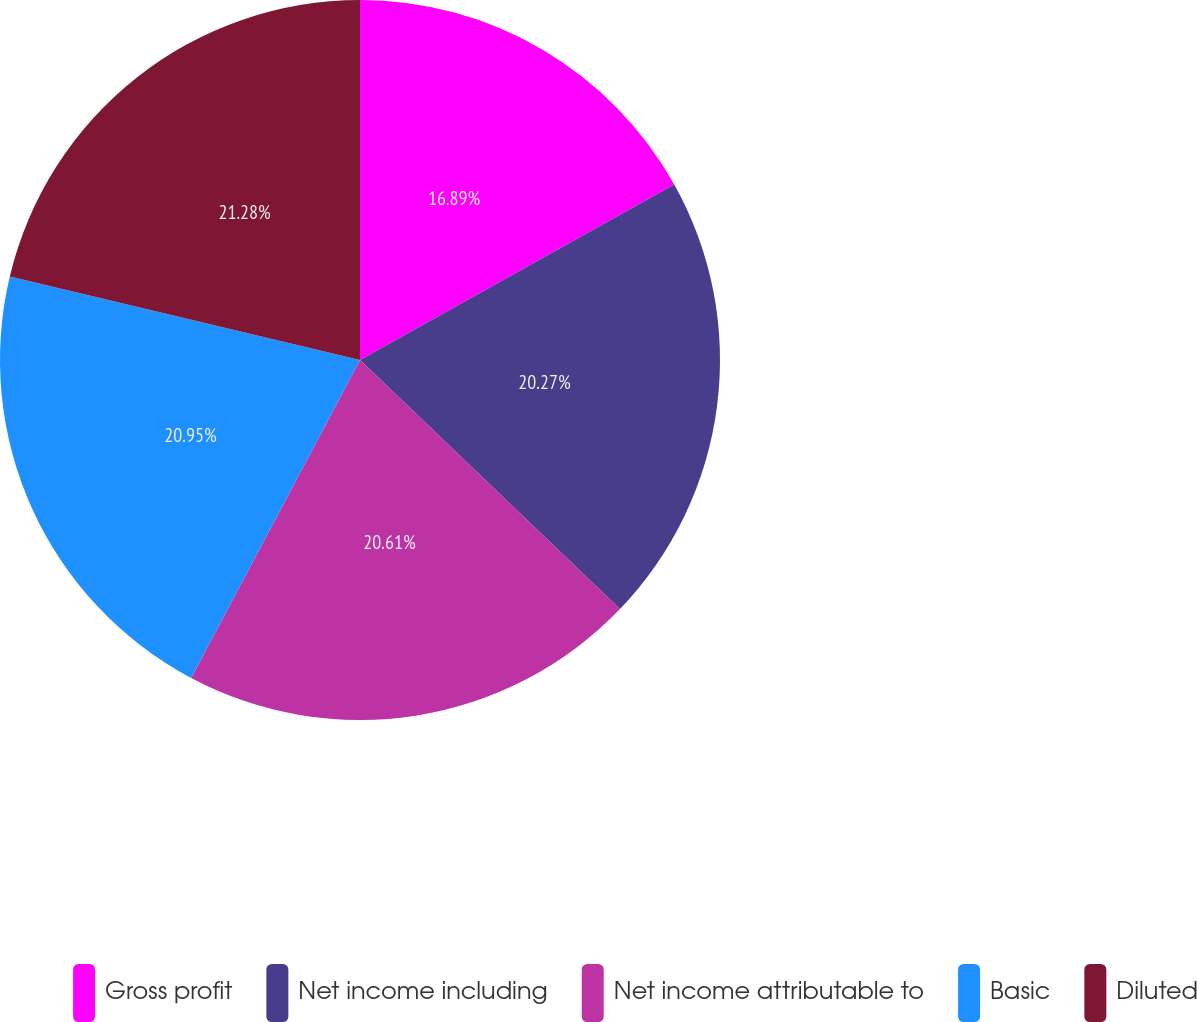Convert chart. <chart><loc_0><loc_0><loc_500><loc_500><pie_chart><fcel>Gross profit<fcel>Net income including<fcel>Net income attributable to<fcel>Basic<fcel>Diluted<nl><fcel>16.89%<fcel>20.27%<fcel>20.61%<fcel>20.95%<fcel>21.28%<nl></chart> 